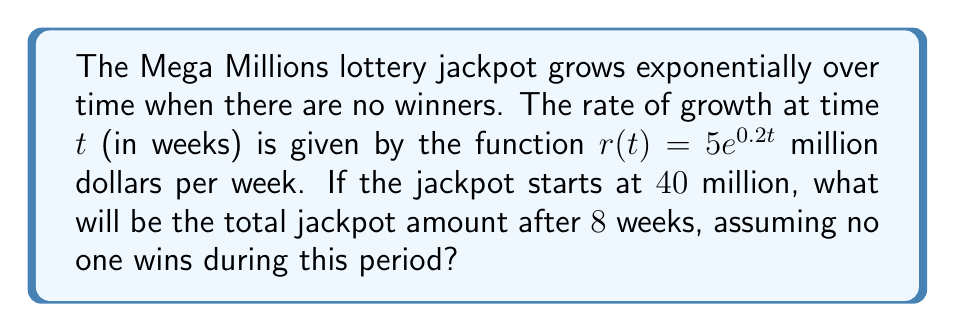Show me your answer to this math problem. Let's approach this step-by-step:

1) The growth rate is given by $r(t) = 5e^{0.2t}$ million dollars per week.

2) To find the total jackpot amount, we need to integrate this rate over the 8-week period and add it to the initial jackpot.

3) The integral we need to calculate is:

   $$\int_0^8 5e^{0.2t} dt$$

4) To solve this integral:
   
   $$\int_0^8 5e^{0.2t} dt = 5 \int_0^8 e^{0.2t} dt = 5 \cdot \frac{1}{0.2} [e^{0.2t}]_0^8$$

5) Evaluating the integral:

   $$5 \cdot \frac{1}{0.2} [e^{0.2t}]_0^8 = 25 [e^{1.6} - e^0] = 25 [4.9530 - 1] = 98.825$$

6) This means the jackpot grew by approximately $98.825$ million dollars over the 8 weeks.

7) Adding this to the initial jackpot:

   $40 + 98.825 = 138.825$ million dollars

Therefore, the total jackpot amount after 8 weeks will be approximately $138.825$ million dollars.
Answer: $138.825$ million dollars 